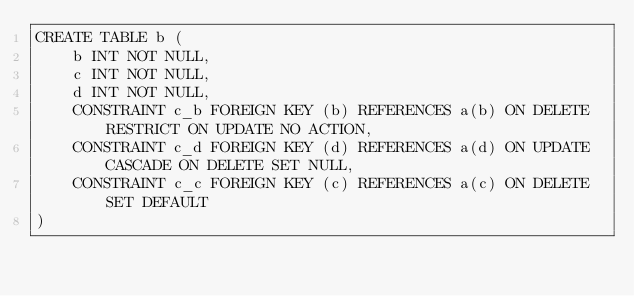<code> <loc_0><loc_0><loc_500><loc_500><_SQL_>CREATE TABLE b (
    b INT NOT NULL,
    c INT NOT NULL,
    d INT NOT NULL,
    CONSTRAINT c_b FOREIGN KEY (b) REFERENCES a(b) ON DELETE RESTRICT ON UPDATE NO ACTION,
    CONSTRAINT c_d FOREIGN KEY (d) REFERENCES a(d) ON UPDATE CASCADE ON DELETE SET NULL,
    CONSTRAINT c_c FOREIGN KEY (c) REFERENCES a(c) ON DELETE SET DEFAULT
)
</code> 